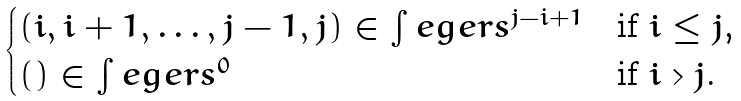Convert formula to latex. <formula><loc_0><loc_0><loc_500><loc_500>\begin{cases} ( i , i + 1 , \dots , j - 1 , j ) \in \int e g e r s ^ { j - i + 1 } & \text {if $i \leq j$,} \\ ( ) \in \int e g e r s ^ { 0 } & \text {if $i > j$.} \end{cases}</formula> 